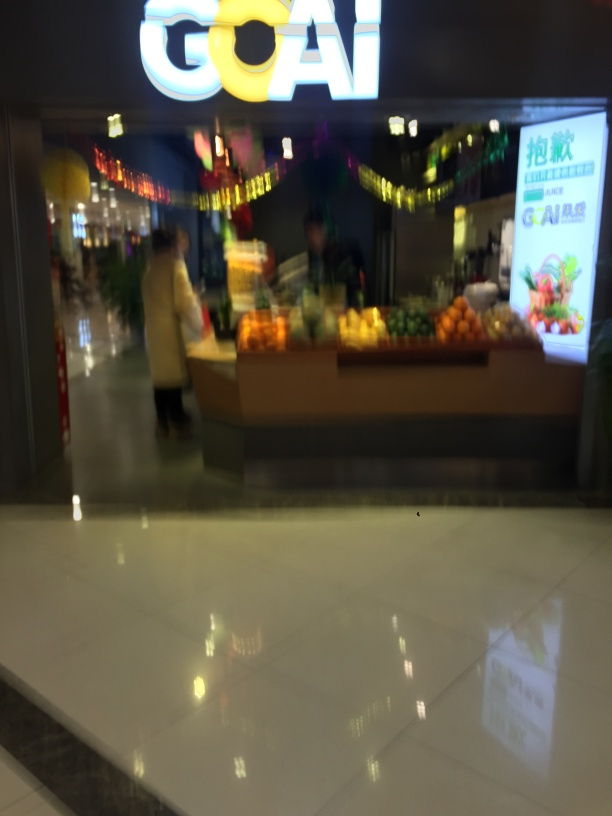Does the image contain noise? Based on the visual analysis, the image does exhibit a significant amount of visual noise, disrupting the clarity of the content. Factors contributing to this may include low lighting conditions, quick movement during capture, or a high ISO setting on the camera. 